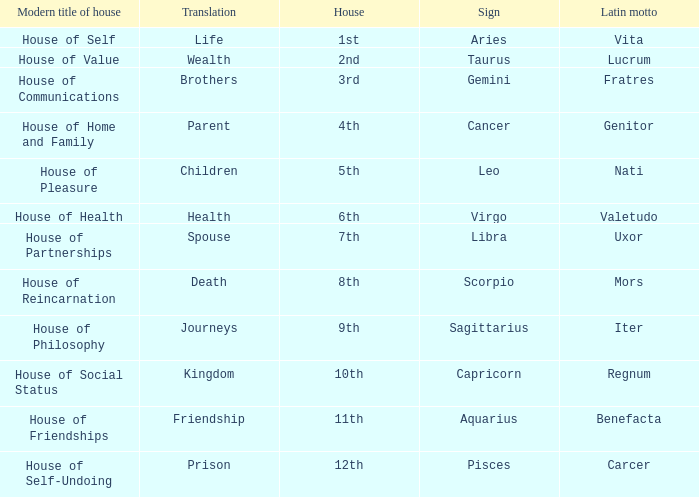What is the translation of the sign of Aquarius? Friendship. Can you give me this table as a dict? {'header': ['Modern title of house', 'Translation', 'House', 'Sign', 'Latin motto'], 'rows': [['House of Self', 'Life', '1st', 'Aries', 'Vita'], ['House of Value', 'Wealth', '2nd', 'Taurus', 'Lucrum'], ['House of Communications', 'Brothers', '3rd', 'Gemini', 'Fratres'], ['House of Home and Family', 'Parent', '4th', 'Cancer', 'Genitor'], ['House of Pleasure', 'Children', '5th', 'Leo', 'Nati'], ['House of Health', 'Health', '6th', 'Virgo', 'Valetudo'], ['House of Partnerships', 'Spouse', '7th', 'Libra', 'Uxor'], ['House of Reincarnation', 'Death', '8th', 'Scorpio', 'Mors'], ['House of Philosophy', 'Journeys', '9th', 'Sagittarius', 'Iter'], ['House of Social Status', 'Kingdom', '10th', 'Capricorn', 'Regnum'], ['House of Friendships', 'Friendship', '11th', 'Aquarius', 'Benefacta'], ['House of Self-Undoing', 'Prison', '12th', 'Pisces', 'Carcer']]} 